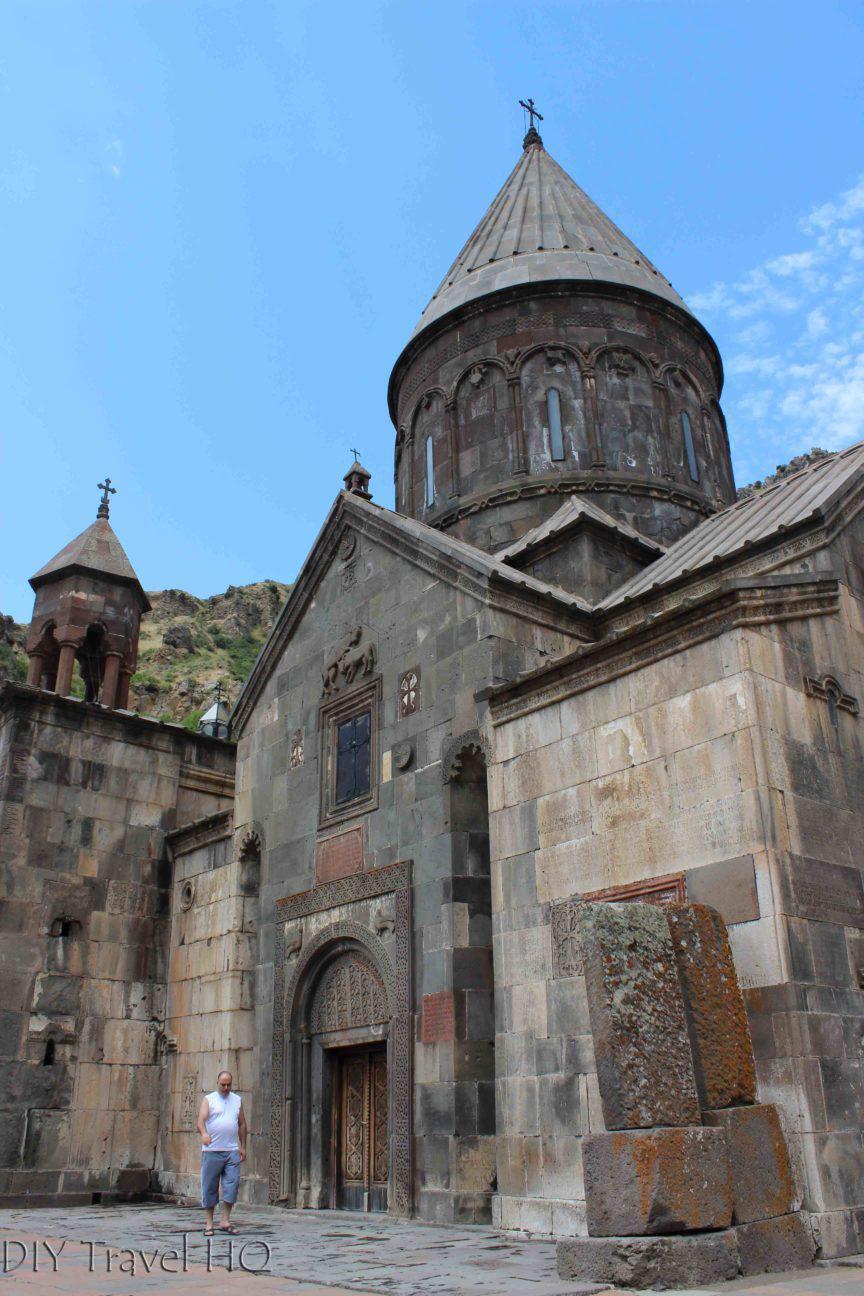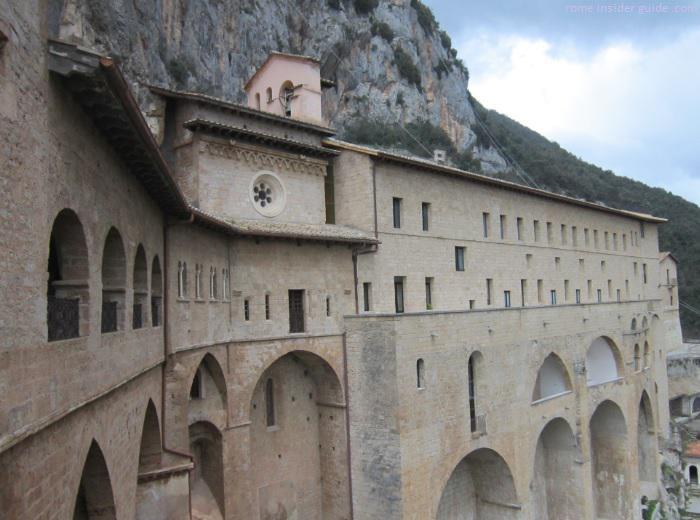The first image is the image on the left, the second image is the image on the right. Assess this claim about the two images: "An image shows a beige building with a row of arch shapes on the bottom, many rectangular windows below a flat roof, and a mountainside in the background.". Correct or not? Answer yes or no. Yes. 